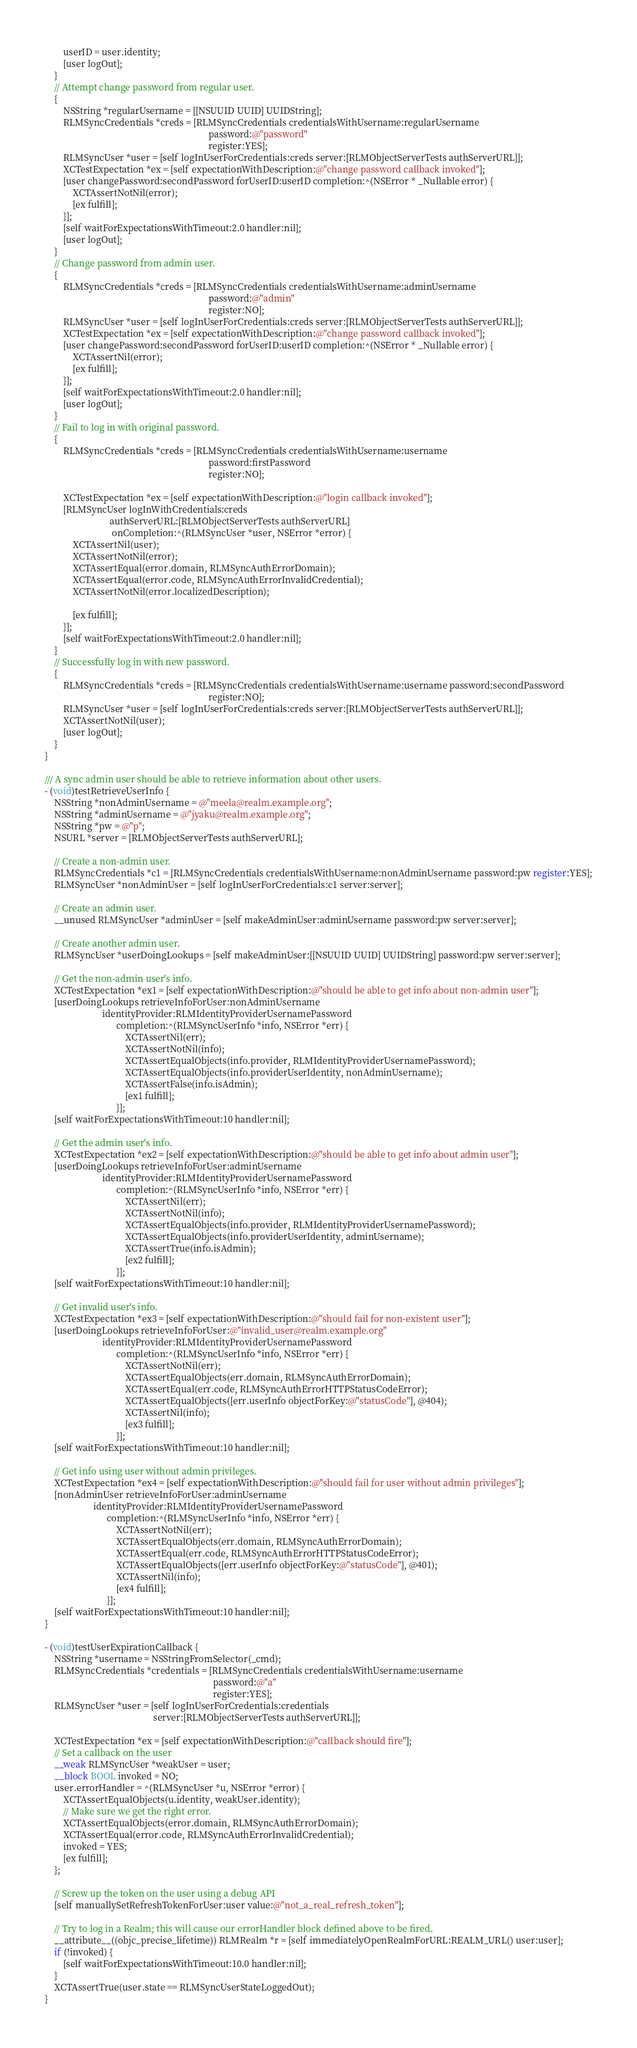Convert code to text. <code><loc_0><loc_0><loc_500><loc_500><_ObjectiveC_>        userID = user.identity;
        [user logOut];
    }
    // Attempt change password from regular user.
    {
        NSString *regularUsername = [[NSUUID UUID] UUIDString];
        RLMSyncCredentials *creds = [RLMSyncCredentials credentialsWithUsername:regularUsername
                                                                       password:@"password"
                                                                       register:YES];
        RLMSyncUser *user = [self logInUserForCredentials:creds server:[RLMObjectServerTests authServerURL]];
        XCTestExpectation *ex = [self expectationWithDescription:@"change password callback invoked"];
        [user changePassword:secondPassword forUserID:userID completion:^(NSError * _Nullable error) {
            XCTAssertNotNil(error);
            [ex fulfill];
        }];
        [self waitForExpectationsWithTimeout:2.0 handler:nil];
        [user logOut];
    }
    // Change password from admin user.
    {
        RLMSyncCredentials *creds = [RLMSyncCredentials credentialsWithUsername:adminUsername
                                                                       password:@"admin"
                                                                       register:NO];
        RLMSyncUser *user = [self logInUserForCredentials:creds server:[RLMObjectServerTests authServerURL]];
        XCTestExpectation *ex = [self expectationWithDescription:@"change password callback invoked"];
        [user changePassword:secondPassword forUserID:userID completion:^(NSError * _Nullable error) {
            XCTAssertNil(error);
            [ex fulfill];
        }];
        [self waitForExpectationsWithTimeout:2.0 handler:nil];
        [user logOut];
    }
    // Fail to log in with original password.
    {
        RLMSyncCredentials *creds = [RLMSyncCredentials credentialsWithUsername:username
                                                                       password:firstPassword
                                                                       register:NO];

        XCTestExpectation *ex = [self expectationWithDescription:@"login callback invoked"];
        [RLMSyncUser logInWithCredentials:creds
                            authServerURL:[RLMObjectServerTests authServerURL]
                             onCompletion:^(RLMSyncUser *user, NSError *error) {
            XCTAssertNil(user);
            XCTAssertNotNil(error);
            XCTAssertEqual(error.domain, RLMSyncAuthErrorDomain);
            XCTAssertEqual(error.code, RLMSyncAuthErrorInvalidCredential);
            XCTAssertNotNil(error.localizedDescription);

            [ex fulfill];
        }];
        [self waitForExpectationsWithTimeout:2.0 handler:nil];
    }
    // Successfully log in with new password.
    {
        RLMSyncCredentials *creds = [RLMSyncCredentials credentialsWithUsername:username password:secondPassword
                                                                       register:NO];
        RLMSyncUser *user = [self logInUserForCredentials:creds server:[RLMObjectServerTests authServerURL]];
        XCTAssertNotNil(user);
        [user logOut];
    }
}

/// A sync admin user should be able to retrieve information about other users.
- (void)testRetrieveUserInfo {
    NSString *nonAdminUsername = @"meela@realm.example.org";
    NSString *adminUsername = @"jyaku@realm.example.org";
    NSString *pw = @"p";
    NSURL *server = [RLMObjectServerTests authServerURL];

    // Create a non-admin user.
    RLMSyncCredentials *c1 = [RLMSyncCredentials credentialsWithUsername:nonAdminUsername password:pw register:YES];
    RLMSyncUser *nonAdminUser = [self logInUserForCredentials:c1 server:server];

    // Create an admin user.
    __unused RLMSyncUser *adminUser = [self makeAdminUser:adminUsername password:pw server:server];

    // Create another admin user.
    RLMSyncUser *userDoingLookups = [self makeAdminUser:[[NSUUID UUID] UUIDString] password:pw server:server];

    // Get the non-admin user's info.
    XCTestExpectation *ex1 = [self expectationWithDescription:@"should be able to get info about non-admin user"];
    [userDoingLookups retrieveInfoForUser:nonAdminUsername
                         identityProvider:RLMIdentityProviderUsernamePassword
                               completion:^(RLMSyncUserInfo *info, NSError *err) {
                                   XCTAssertNil(err);
                                   XCTAssertNotNil(info);
                                   XCTAssertEqualObjects(info.provider, RLMIdentityProviderUsernamePassword);
                                   XCTAssertEqualObjects(info.providerUserIdentity, nonAdminUsername);
                                   XCTAssertFalse(info.isAdmin);
                                   [ex1 fulfill];
                               }];
    [self waitForExpectationsWithTimeout:10 handler:nil];

    // Get the admin user's info.
    XCTestExpectation *ex2 = [self expectationWithDescription:@"should be able to get info about admin user"];
    [userDoingLookups retrieveInfoForUser:adminUsername
                         identityProvider:RLMIdentityProviderUsernamePassword
                               completion:^(RLMSyncUserInfo *info, NSError *err) {
                                   XCTAssertNil(err);
                                   XCTAssertNotNil(info);
                                   XCTAssertEqualObjects(info.provider, RLMIdentityProviderUsernamePassword);
                                   XCTAssertEqualObjects(info.providerUserIdentity, adminUsername);
                                   XCTAssertTrue(info.isAdmin);
                                   [ex2 fulfill];
                               }];
    [self waitForExpectationsWithTimeout:10 handler:nil];

    // Get invalid user's info.
    XCTestExpectation *ex3 = [self expectationWithDescription:@"should fail for non-existent user"];
    [userDoingLookups retrieveInfoForUser:@"invalid_user@realm.example.org"
                         identityProvider:RLMIdentityProviderUsernamePassword
                               completion:^(RLMSyncUserInfo *info, NSError *err) {
                                   XCTAssertNotNil(err);
                                   XCTAssertEqualObjects(err.domain, RLMSyncAuthErrorDomain);
                                   XCTAssertEqual(err.code, RLMSyncAuthErrorHTTPStatusCodeError);
                                   XCTAssertEqualObjects([err.userInfo objectForKey:@"statusCode"], @404);
                                   XCTAssertNil(info);
                                   [ex3 fulfill];
                               }];
    [self waitForExpectationsWithTimeout:10 handler:nil];

    // Get info using user without admin privileges.
    XCTestExpectation *ex4 = [self expectationWithDescription:@"should fail for user without admin privileges"];
    [nonAdminUser retrieveInfoForUser:adminUsername
                     identityProvider:RLMIdentityProviderUsernamePassword
                           completion:^(RLMSyncUserInfo *info, NSError *err) {
                               XCTAssertNotNil(err);
                               XCTAssertEqualObjects(err.domain, RLMSyncAuthErrorDomain);
                               XCTAssertEqual(err.code, RLMSyncAuthErrorHTTPStatusCodeError);
                               XCTAssertEqualObjects([err.userInfo objectForKey:@"statusCode"], @401);
                               XCTAssertNil(info);
                               [ex4 fulfill];
                           }];
    [self waitForExpectationsWithTimeout:10 handler:nil];
}

- (void)testUserExpirationCallback {
    NSString *username = NSStringFromSelector(_cmd);
    RLMSyncCredentials *credentials = [RLMSyncCredentials credentialsWithUsername:username
                                                                         password:@"a"
                                                                         register:YES];
    RLMSyncUser *user = [self logInUserForCredentials:credentials
                                               server:[RLMObjectServerTests authServerURL]];

    XCTestExpectation *ex = [self expectationWithDescription:@"callback should fire"];
    // Set a callback on the user
    __weak RLMSyncUser *weakUser = user;
    __block BOOL invoked = NO;
    user.errorHandler = ^(RLMSyncUser *u, NSError *error) {
        XCTAssertEqualObjects(u.identity, weakUser.identity);
        // Make sure we get the right error.
        XCTAssertEqualObjects(error.domain, RLMSyncAuthErrorDomain);
        XCTAssertEqual(error.code, RLMSyncAuthErrorInvalidCredential);
        invoked = YES;
        [ex fulfill];
    };

    // Screw up the token on the user using a debug API
    [self manuallySetRefreshTokenForUser:user value:@"not_a_real_refresh_token"];

    // Try to log in a Realm; this will cause our errorHandler block defined above to be fired.
    __attribute__((objc_precise_lifetime)) RLMRealm *r = [self immediatelyOpenRealmForURL:REALM_URL() user:user];
    if (!invoked) {
        [self waitForExpectationsWithTimeout:10.0 handler:nil];
    }
    XCTAssertTrue(user.state == RLMSyncUserStateLoggedOut);
}
</code> 